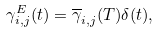<formula> <loc_0><loc_0><loc_500><loc_500>\gamma _ { i , j } ^ { E } ( t ) = \overline { \gamma } _ { i , j } ( T ) \delta ( t ) ,</formula> 